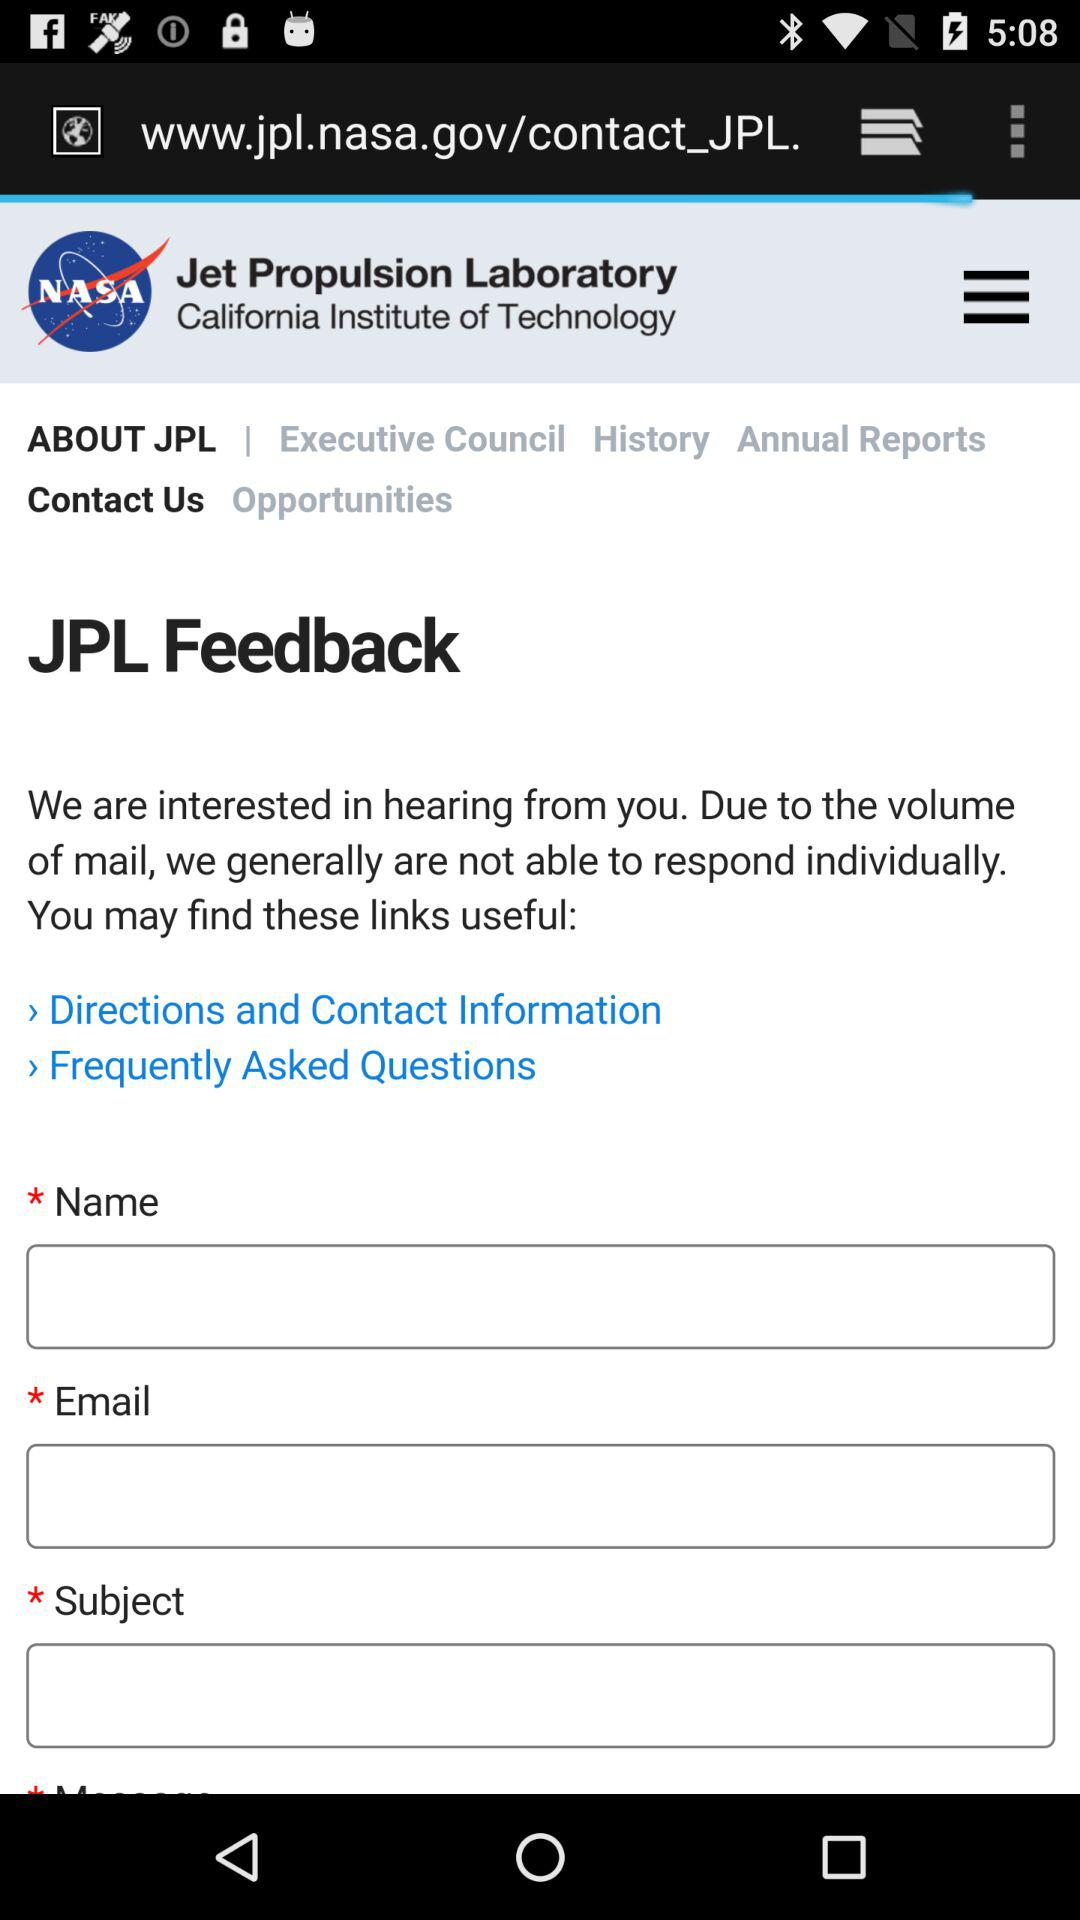What is the name of the shown Laboratory? The name of the laboratory is "Jet Propulsion Laboratory". 